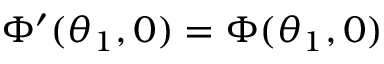Convert formula to latex. <formula><loc_0><loc_0><loc_500><loc_500>\Phi ^ { \prime } ( \theta _ { 1 } , 0 ) = \Phi ( \theta _ { 1 } , 0 )</formula> 